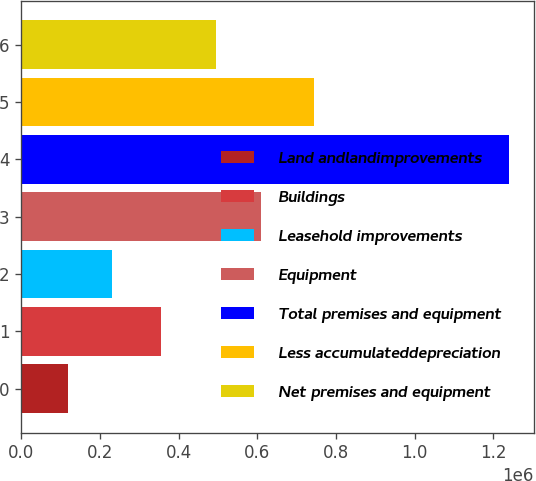Convert chart. <chart><loc_0><loc_0><loc_500><loc_500><bar_chart><fcel>Land andlandimprovements<fcel>Buildings<fcel>Leasehold improvements<fcel>Equipment<fcel>Total premises and equipment<fcel>Less accumulateddepreciation<fcel>Net premises and equipment<nl><fcel>118875<fcel>355352<fcel>230981<fcel>608127<fcel>1.23994e+06<fcel>743918<fcel>496021<nl></chart> 